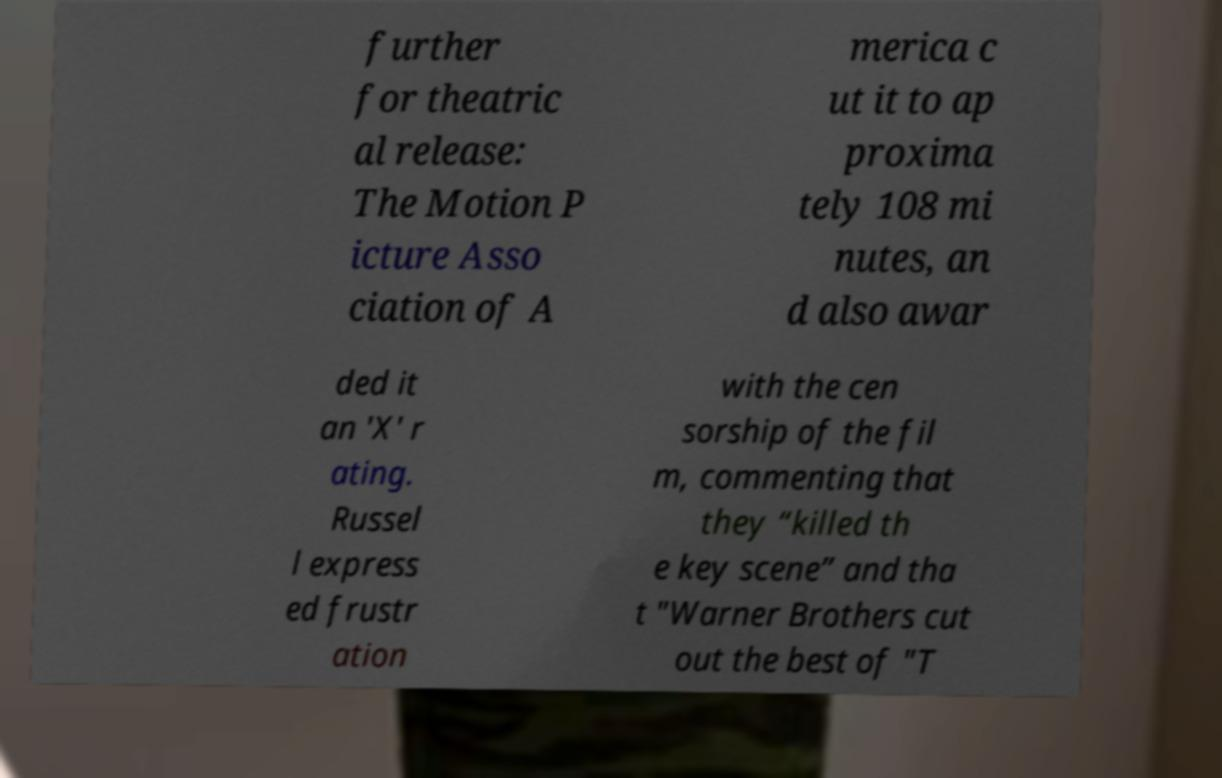What messages or text are displayed in this image? I need them in a readable, typed format. further for theatric al release: The Motion P icture Asso ciation of A merica c ut it to ap proxima tely 108 mi nutes, an d also awar ded it an 'X' r ating. Russel l express ed frustr ation with the cen sorship of the fil m, commenting that they “killed th e key scene” and tha t "Warner Brothers cut out the best of "T 